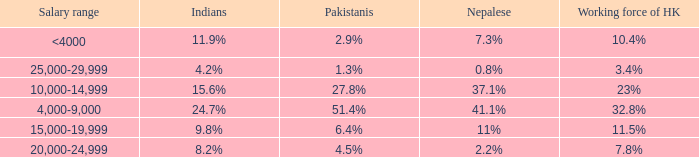If the Indians are 8.2%, what is the salary range? 20,000-24,999. 